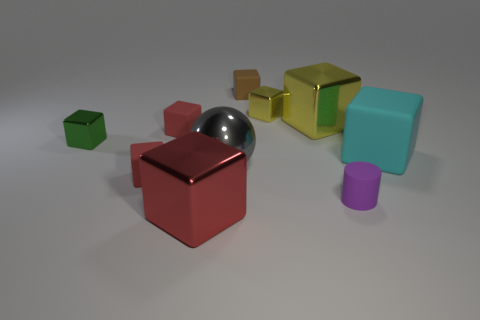What color is the large metal block that is in front of the tiny shiny block that is left of the tiny rubber cube on the right side of the red metal object?
Offer a very short reply. Red. What is the size of the red metal object in front of the large cyan rubber object?
Your answer should be compact. Large. What number of big objects are either gray things or gray metal blocks?
Your answer should be compact. 1. What color is the metallic cube that is both on the left side of the brown cube and on the right side of the small green thing?
Offer a terse response. Red. Is there another big cyan rubber object that has the same shape as the large rubber object?
Your answer should be compact. No. What is the large red block made of?
Your response must be concise. Metal. There is a purple object; are there any red cubes on the right side of it?
Provide a short and direct response. No. Does the small green object have the same shape as the big gray thing?
Make the answer very short. No. How many other things are there of the same size as the cyan cube?
Your answer should be compact. 3. How many objects are either tiny red objects that are in front of the big gray sphere or tiny red cubes?
Ensure brevity in your answer.  2. 